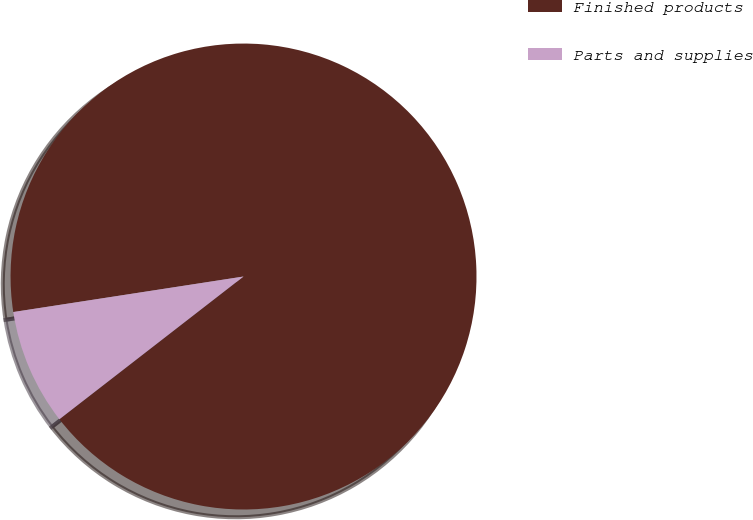<chart> <loc_0><loc_0><loc_500><loc_500><pie_chart><fcel>Finished products<fcel>Parts and supplies<nl><fcel>91.94%<fcel>8.06%<nl></chart> 